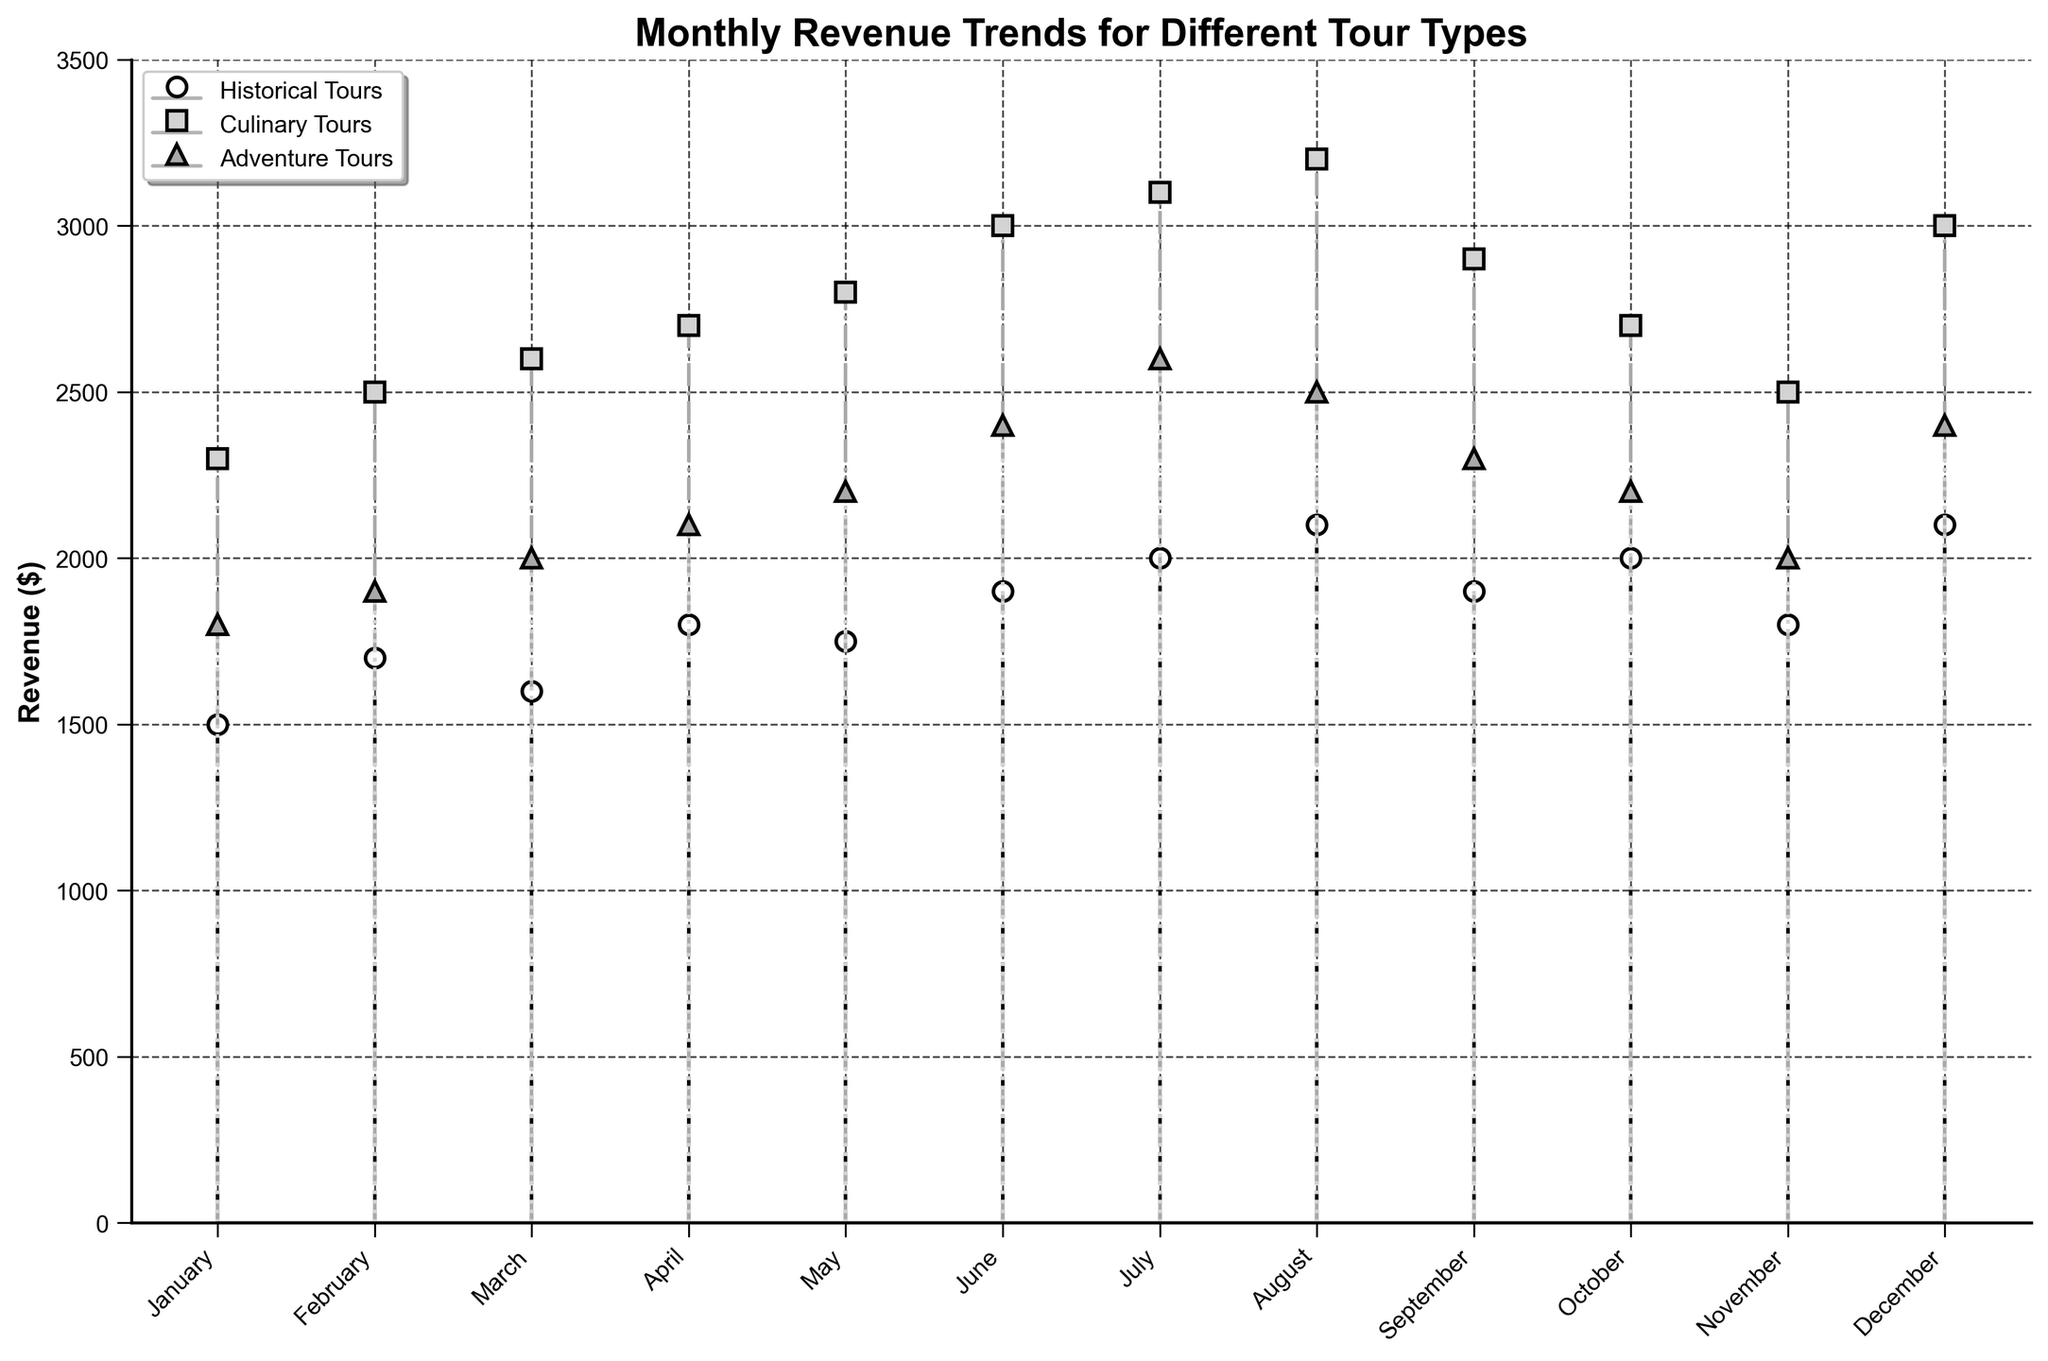What is the title of the figure? The title is located at the top of the figure and reads "Monthly Revenue Trends for Different Tour Types."
Answer: Monthly Revenue Trends for Different Tour Types Which tour type has the highest revenue in July? Locate July on the x-axis and observe the corresponding markers for each tour type. The highest revenue marker belongs to Culinary Tours at $3100.
Answer: Culinary Tours How does the revenue from Historical Tours change from January to February? Find the markers for Historical Tours in January and February. January shows $1500, and February shows $1700. The difference is an increase of $200.
Answer: Increases by $200 What is the total revenue for Adventure Tours in the first quarter (January to March)? Add the revenue for Adventure Tours in January ($1800), February ($1900), and March ($2000). The total sum is $5700.
Answer: $5700 Which month has the highest overall revenue for any tour type? Compare the highest revenue markers for each month. Culinary Tours in August has the highest revenue at $3200.
Answer: August What is the average revenue for Culinary Tours in the second quarter (April to June)? Sum the revenue for Culinary Tours in April ($2700), May ($2800), and June ($3000), then divide by 3. The average is ($2700 + $2800 + $3000) / 3 = $2833.33.
Answer: $2833.33 Does the revenue from Adventure Tours ever exceed $2500? If so, in which months? Observe the Adventure Tours markers and check if any exceed $2500. They surpass $2500 in July ($2600) and December ($2400).
Answer: Yes, in July and December How does the revenue trend for Historical Tours compare between April and October? Compare the Historical Tours markers for April ($1800) and October ($2000). Revenue increases by $200 in October compared to April.
Answer: Increases by $200 Which tour type shows the most consistent revenue growth across the year? Evaluate the markers for each tour type across the months. Culinary Tours demonstrate the most consistent increase in revenue each month.
Answer: Culinary Tours What is the revenue difference between the peak and lowest months for Historical Tours? Identify the peak revenue month for Historical Tours (August, $2100) and the lowest (January, $1500). The difference is $2100 - $1500 = $600.
Answer: $600 